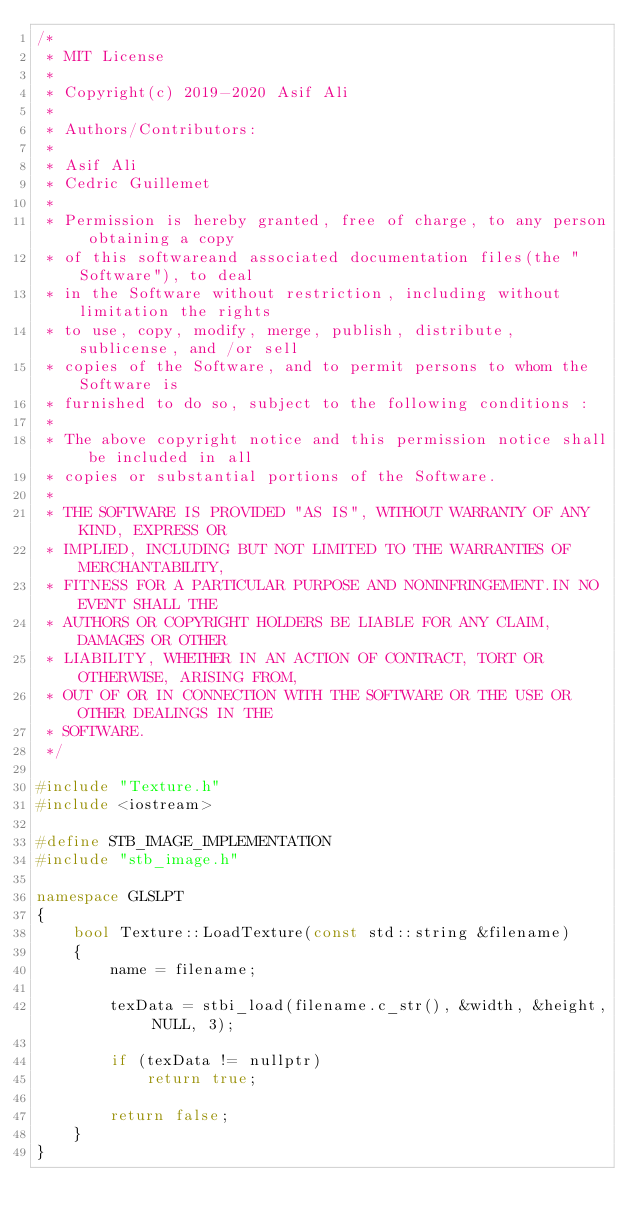Convert code to text. <code><loc_0><loc_0><loc_500><loc_500><_C++_>/*
 * MIT License
 *
 * Copyright(c) 2019-2020 Asif Ali
 *
 * Authors/Contributors:
 *
 * Asif Ali
 * Cedric Guillemet
 *
 * Permission is hereby granted, free of charge, to any person obtaining a copy
 * of this softwareand associated documentation files(the "Software"), to deal
 * in the Software without restriction, including without limitation the rights
 * to use, copy, modify, merge, publish, distribute, sublicense, and /or sell
 * copies of the Software, and to permit persons to whom the Software is
 * furnished to do so, subject to the following conditions :
 *
 * The above copyright notice and this permission notice shall be included in all
 * copies or substantial portions of the Software.
 *
 * THE SOFTWARE IS PROVIDED "AS IS", WITHOUT WARRANTY OF ANY KIND, EXPRESS OR
 * IMPLIED, INCLUDING BUT NOT LIMITED TO THE WARRANTIES OF MERCHANTABILITY,
 * FITNESS FOR A PARTICULAR PURPOSE AND NONINFRINGEMENT.IN NO EVENT SHALL THE
 * AUTHORS OR COPYRIGHT HOLDERS BE LIABLE FOR ANY CLAIM, DAMAGES OR OTHER
 * LIABILITY, WHETHER IN AN ACTION OF CONTRACT, TORT OR OTHERWISE, ARISING FROM,
 * OUT OF OR IN CONNECTION WITH THE SOFTWARE OR THE USE OR OTHER DEALINGS IN THE
 * SOFTWARE.
 */

#include "Texture.h"
#include <iostream>

#define STB_IMAGE_IMPLEMENTATION
#include "stb_image.h"

namespace GLSLPT
{
    bool Texture::LoadTexture(const std::string &filename)
    {
        name = filename;

        texData = stbi_load(filename.c_str(), &width, &height, NULL, 3);

        if (texData != nullptr)
            return true;

        return false;
    }
}</code> 